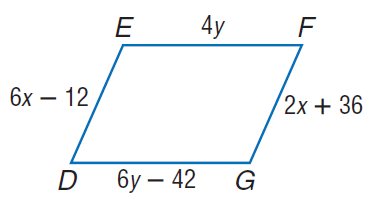Answer the mathemtical geometry problem and directly provide the correct option letter.
Question: Find y so that the quadrilateral is a parallelogram.
Choices: A: 21 B: 30 C: 42 D: 84 A 